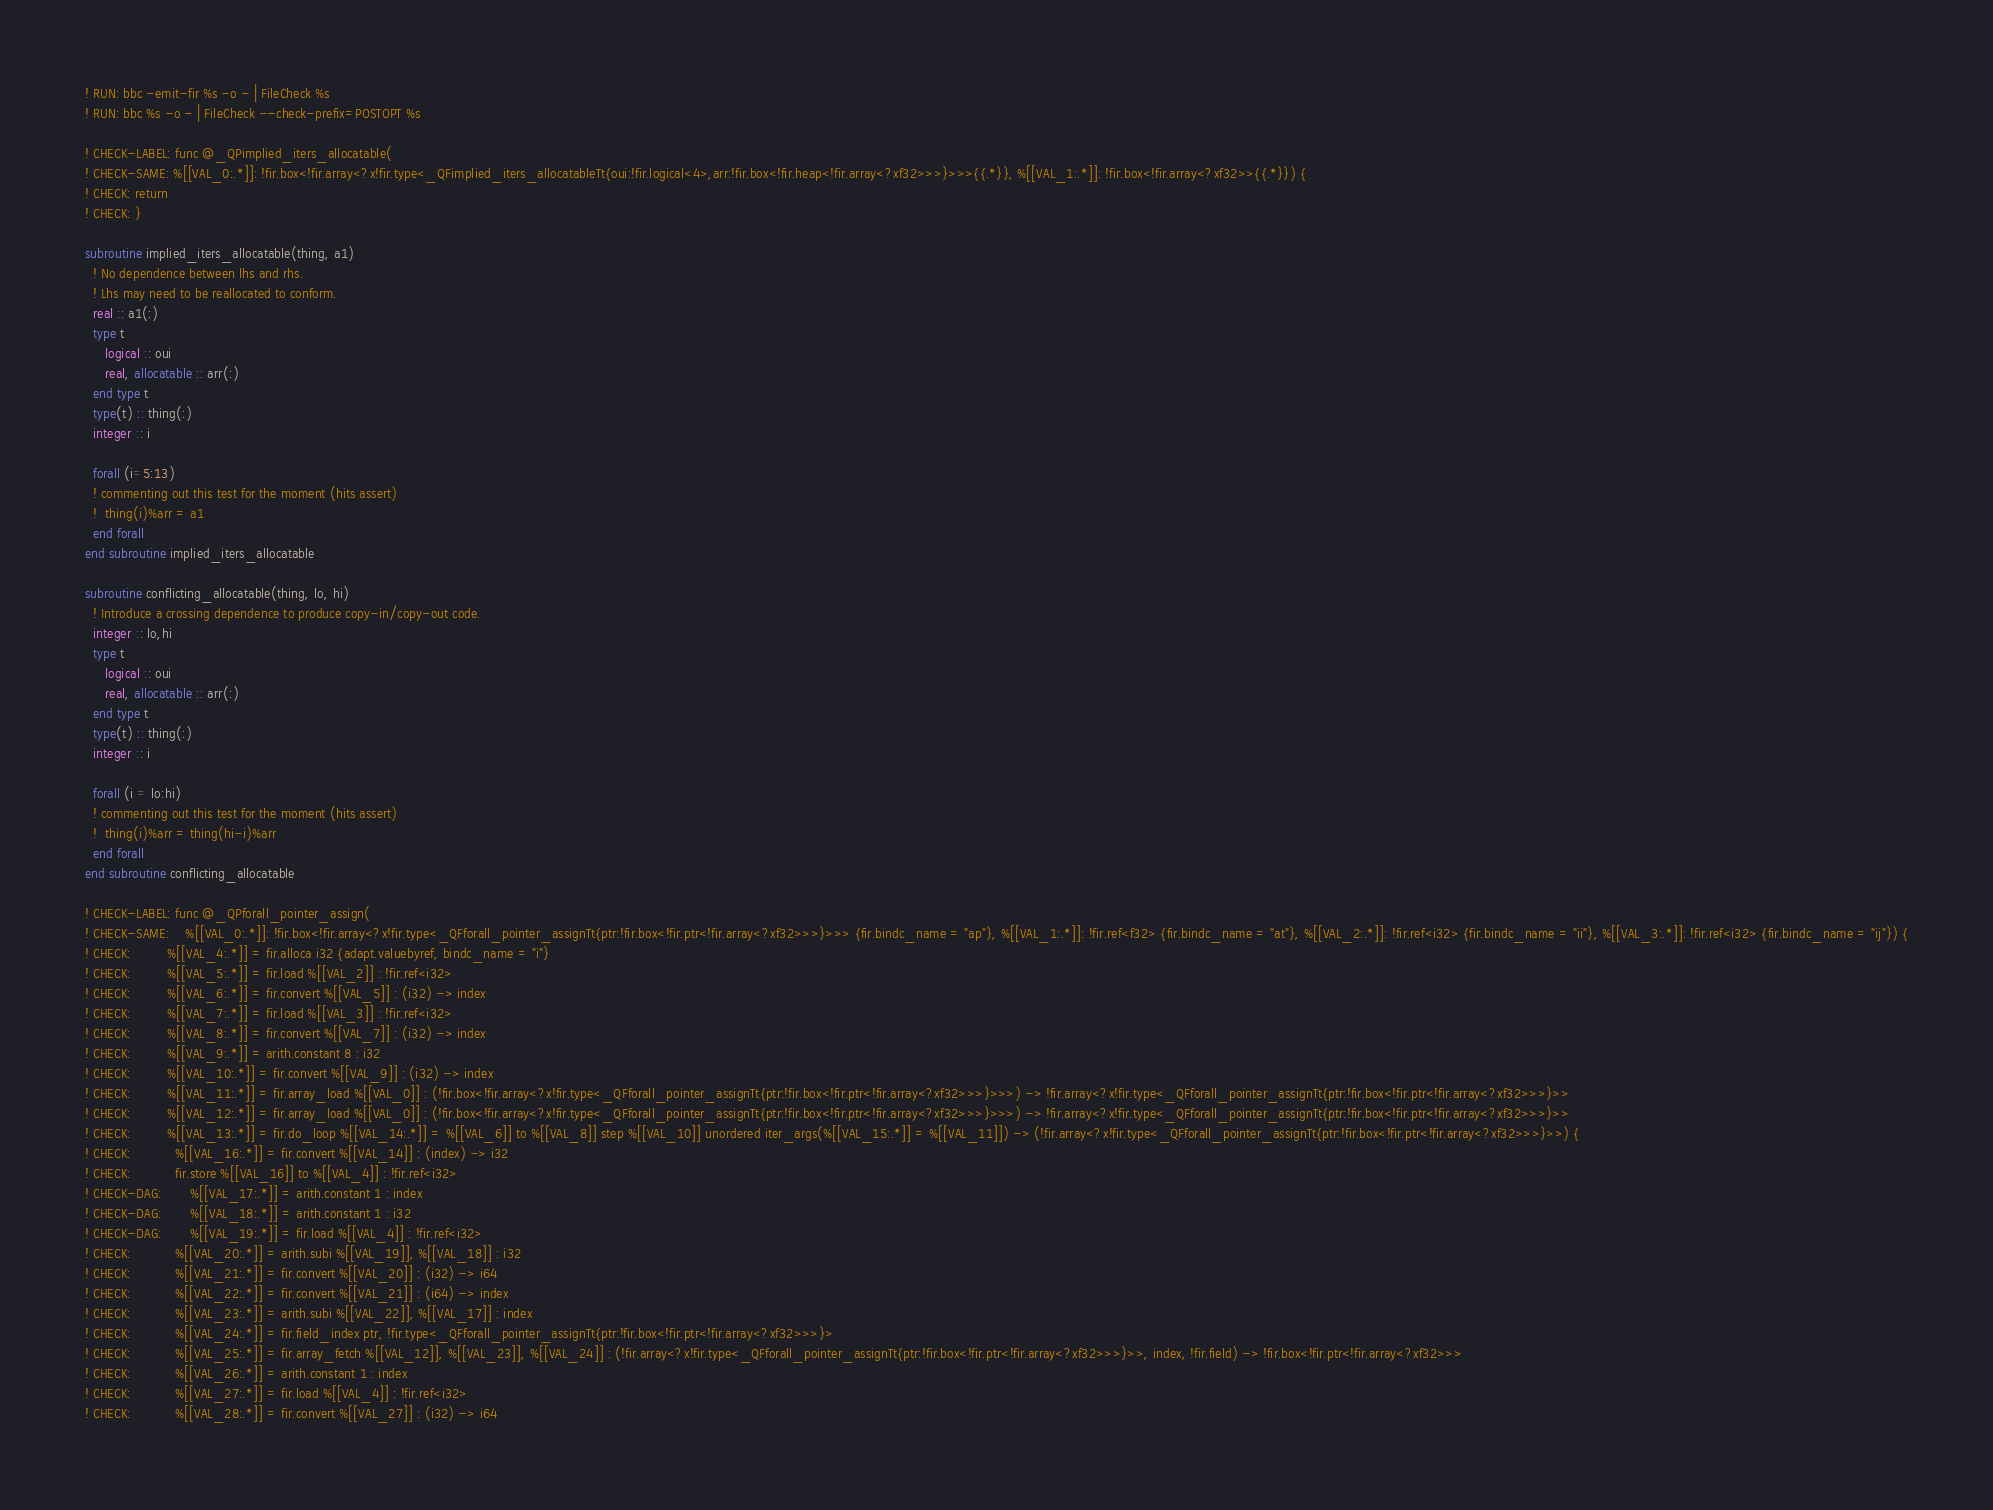<code> <loc_0><loc_0><loc_500><loc_500><_FORTRAN_>! RUN: bbc -emit-fir %s -o - | FileCheck %s
! RUN: bbc %s -o - | FileCheck --check-prefix=POSTOPT %s

! CHECK-LABEL: func @_QPimplied_iters_allocatable(
! CHECK-SAME: %[[VAL_0:.*]]: !fir.box<!fir.array<?x!fir.type<_QFimplied_iters_allocatableTt{oui:!fir.logical<4>,arr:!fir.box<!fir.heap<!fir.array<?xf32>>>}>>>{{.*}}, %[[VAL_1:.*]]: !fir.box<!fir.array<?xf32>>{{.*}}) {
! CHECK: return
! CHECK: }

subroutine implied_iters_allocatable(thing, a1)
  ! No dependence between lhs and rhs.
  ! Lhs may need to be reallocated to conform.
  real :: a1(:)
  type t
     logical :: oui
     real, allocatable :: arr(:)
  end type t
  type(t) :: thing(:)
  integer :: i
  
  forall (i=5:13)
  ! commenting out this test for the moment (hits assert)
  !  thing(i)%arr = a1
  end forall
end subroutine implied_iters_allocatable

subroutine conflicting_allocatable(thing, lo, hi)
  ! Introduce a crossing dependence to produce copy-in/copy-out code.
  integer :: lo,hi
  type t
     logical :: oui
     real, allocatable :: arr(:)
  end type t
  type(t) :: thing(:)
  integer :: i
  
  forall (i = lo:hi)
  ! commenting out this test for the moment (hits assert)
  !  thing(i)%arr = thing(hi-i)%arr
  end forall
end subroutine conflicting_allocatable

! CHECK-LABEL: func @_QPforall_pointer_assign(
! CHECK-SAME:    %[[VAL_0:.*]]: !fir.box<!fir.array<?x!fir.type<_QFforall_pointer_assignTt{ptr:!fir.box<!fir.ptr<!fir.array<?xf32>>>}>>> {fir.bindc_name = "ap"}, %[[VAL_1:.*]]: !fir.ref<f32> {fir.bindc_name = "at"}, %[[VAL_2:.*]]: !fir.ref<i32> {fir.bindc_name = "ii"}, %[[VAL_3:.*]]: !fir.ref<i32> {fir.bindc_name = "ij"}) {
! CHECK:         %[[VAL_4:.*]] = fir.alloca i32 {adapt.valuebyref, bindc_name = "i"}
! CHECK:         %[[VAL_5:.*]] = fir.load %[[VAL_2]] : !fir.ref<i32>
! CHECK:         %[[VAL_6:.*]] = fir.convert %[[VAL_5]] : (i32) -> index
! CHECK:         %[[VAL_7:.*]] = fir.load %[[VAL_3]] : !fir.ref<i32>
! CHECK:         %[[VAL_8:.*]] = fir.convert %[[VAL_7]] : (i32) -> index
! CHECK:         %[[VAL_9:.*]] = arith.constant 8 : i32
! CHECK:         %[[VAL_10:.*]] = fir.convert %[[VAL_9]] : (i32) -> index
! CHECK:         %[[VAL_11:.*]] = fir.array_load %[[VAL_0]] : (!fir.box<!fir.array<?x!fir.type<_QFforall_pointer_assignTt{ptr:!fir.box<!fir.ptr<!fir.array<?xf32>>>}>>>) -> !fir.array<?x!fir.type<_QFforall_pointer_assignTt{ptr:!fir.box<!fir.ptr<!fir.array<?xf32>>>}>>
! CHECK:         %[[VAL_12:.*]] = fir.array_load %[[VAL_0]] : (!fir.box<!fir.array<?x!fir.type<_QFforall_pointer_assignTt{ptr:!fir.box<!fir.ptr<!fir.array<?xf32>>>}>>>) -> !fir.array<?x!fir.type<_QFforall_pointer_assignTt{ptr:!fir.box<!fir.ptr<!fir.array<?xf32>>>}>>
! CHECK:         %[[VAL_13:.*]] = fir.do_loop %[[VAL_14:.*]] = %[[VAL_6]] to %[[VAL_8]] step %[[VAL_10]] unordered iter_args(%[[VAL_15:.*]] = %[[VAL_11]]) -> (!fir.array<?x!fir.type<_QFforall_pointer_assignTt{ptr:!fir.box<!fir.ptr<!fir.array<?xf32>>>}>>) {
! CHECK:           %[[VAL_16:.*]] = fir.convert %[[VAL_14]] : (index) -> i32
! CHECK:           fir.store %[[VAL_16]] to %[[VAL_4]] : !fir.ref<i32>
! CHECK-DAG:       %[[VAL_17:.*]] = arith.constant 1 : index
! CHECK-DAG:       %[[VAL_18:.*]] = arith.constant 1 : i32
! CHECK-DAG:       %[[VAL_19:.*]] = fir.load %[[VAL_4]] : !fir.ref<i32>
! CHECK:           %[[VAL_20:.*]] = arith.subi %[[VAL_19]], %[[VAL_18]] : i32
! CHECK:           %[[VAL_21:.*]] = fir.convert %[[VAL_20]] : (i32) -> i64
! CHECK:           %[[VAL_22:.*]] = fir.convert %[[VAL_21]] : (i64) -> index
! CHECK:           %[[VAL_23:.*]] = arith.subi %[[VAL_22]], %[[VAL_17]] : index
! CHECK:           %[[VAL_24:.*]] = fir.field_index ptr, !fir.type<_QFforall_pointer_assignTt{ptr:!fir.box<!fir.ptr<!fir.array<?xf32>>>}>
! CHECK:           %[[VAL_25:.*]] = fir.array_fetch %[[VAL_12]], %[[VAL_23]], %[[VAL_24]] : (!fir.array<?x!fir.type<_QFforall_pointer_assignTt{ptr:!fir.box<!fir.ptr<!fir.array<?xf32>>>}>>, index, !fir.field) -> !fir.box<!fir.ptr<!fir.array<?xf32>>>
! CHECK:           %[[VAL_26:.*]] = arith.constant 1 : index
! CHECK:           %[[VAL_27:.*]] = fir.load %[[VAL_4]] : !fir.ref<i32>
! CHECK:           %[[VAL_28:.*]] = fir.convert %[[VAL_27]] : (i32) -> i64</code> 